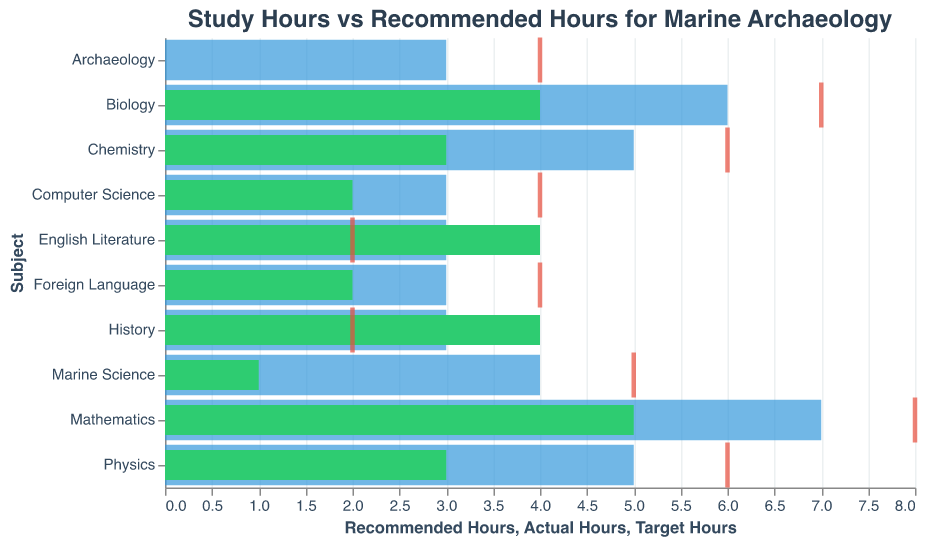How many actual hours are spent on Marine Science and Archaeology combined? Combine the actual hours spent on both subjects. Marine Science has 1 hour and Archaeology has 0 hours. The total is 1+0=1
Answer: 1 Which subject has the greatest difference between actual and recommended hours? Calculate the difference for each subject between actual and recommended hours: Mathematics (7-5=2), Biology (6-4=2), Chemistry (5-3=2), Physics (5-3=2), History (4-3=1), English Literature (4-3=1), Foreign Language (3-2=1), Marine Science (4-1=3), Archaeology (3-0=3), Computer Science (3-2=1). Marine Science and Archaeology both have the greatest difference (3 hours).
Answer: Marine Science, Archaeology How many subjects have actual study hours that exceed the recommended hours? Compare actual hours to recommended hours for each subject. Only History and English Literature have actual study hours greater than the recommended hours (4>3).
Answer: 2 What is the total number of target hours recommended for Mathematics, Chemistry, and Physics? Sum the target hours for Mathematics (8), Chemistry (6), and Physics (6). The total is 8+6+6=20
Answer: 20 Which subject needs the most additional hours to meet the target hours? Calculate the difference between target hours and actual hours for each subject: Mathematics (8-5=3), Biology (7-4=3), Chemistry (6-3=3), Physics (6-3=3), History (2-4=-2), English Literature (2-4=-2), Foreign Language (4-2=2), Marine Science (5-1=4), Archaeology (4-0=4), Computer Science (4-2=2). Marine Science and Archaeology both need 4 additional hours.
Answer: Marine Science, Archaeology Which subject requires the least number of additional hours to meet the recommended hours, excluding subjects where the actual hours are already more than recommended? Exclude subjects where actual hours exceed recommended. Calculate the difference for the remaining: Mathematics (7-5=2), Biology (6-4=2), Chemistry (5-3=2), Physics (5-3=2), Foreign Language (3-2=1), Marine Science (4-1=3), Archaeology (3-0=3), Computer Science (3-2=1). Foreign Language and Computer Science need the least additional hours (1 hour).
Answer: Foreign Language, Computer Science 